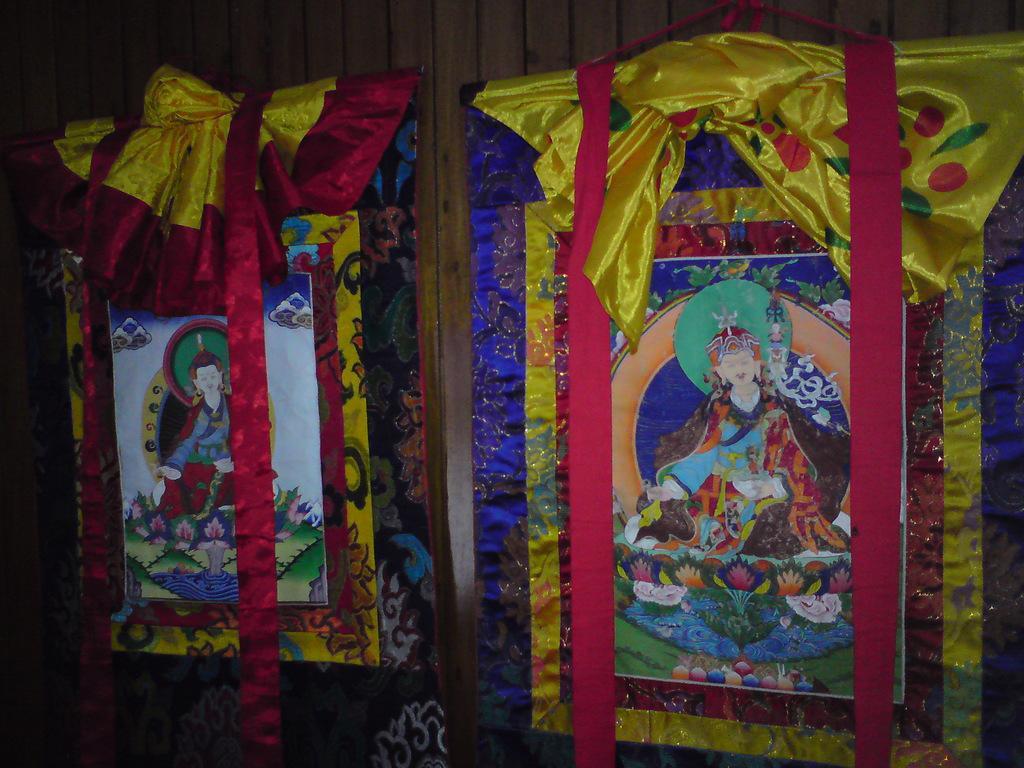In one or two sentences, can you explain what this image depicts? In the image we can see a wooden wall, on the wall there are some frames. 